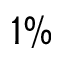<formula> <loc_0><loc_0><loc_500><loc_500>1 \%</formula> 